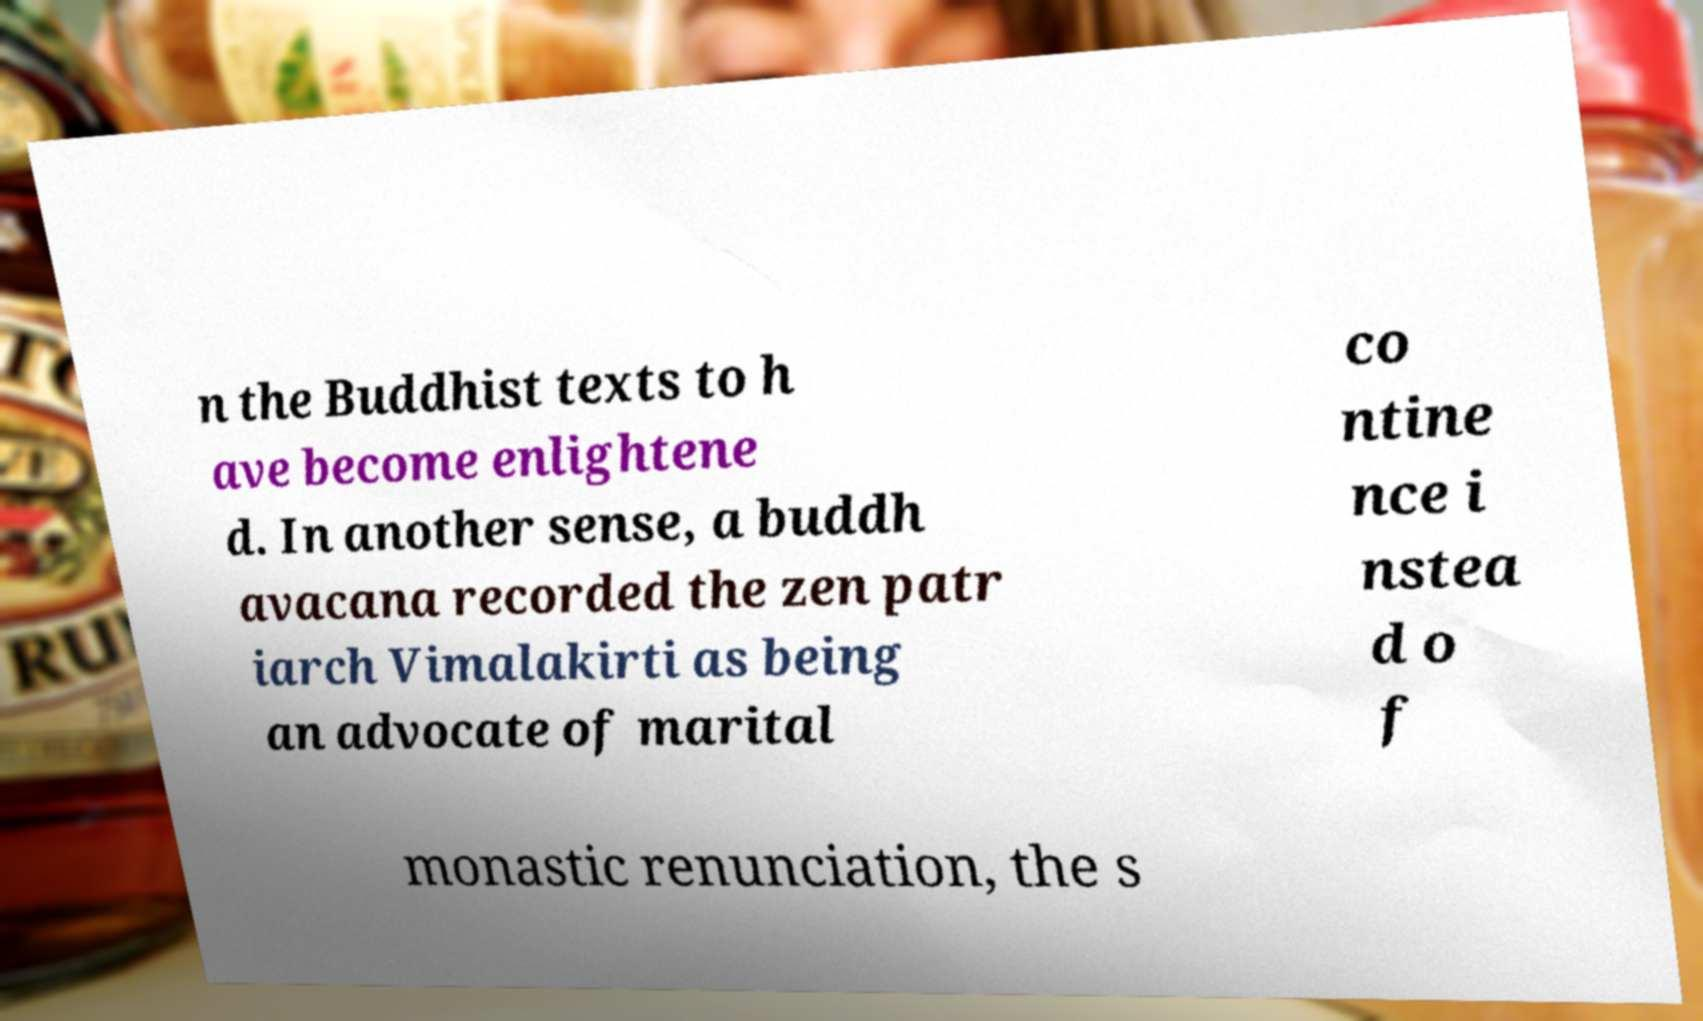Please read and relay the text visible in this image. What does it say? n the Buddhist texts to h ave become enlightene d. In another sense, a buddh avacana recorded the zen patr iarch Vimalakirti as being an advocate of marital co ntine nce i nstea d o f monastic renunciation, the s 